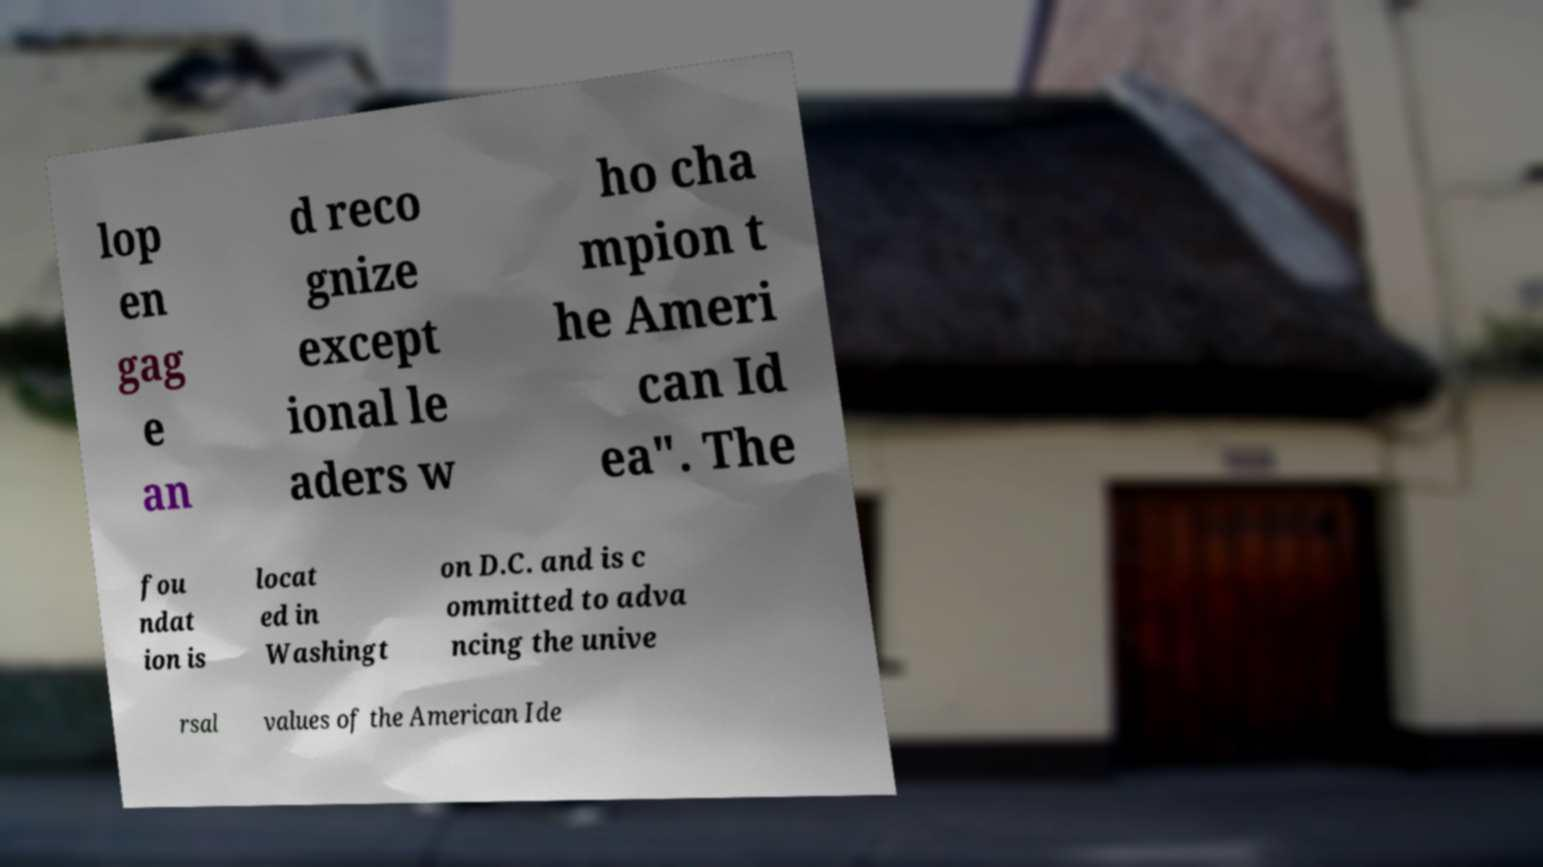Please read and relay the text visible in this image. What does it say? lop en gag e an d reco gnize except ional le aders w ho cha mpion t he Ameri can Id ea". The fou ndat ion is locat ed in Washingt on D.C. and is c ommitted to adva ncing the unive rsal values of the American Ide 